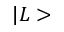Convert formula to latex. <formula><loc_0><loc_0><loc_500><loc_500>| L ></formula> 